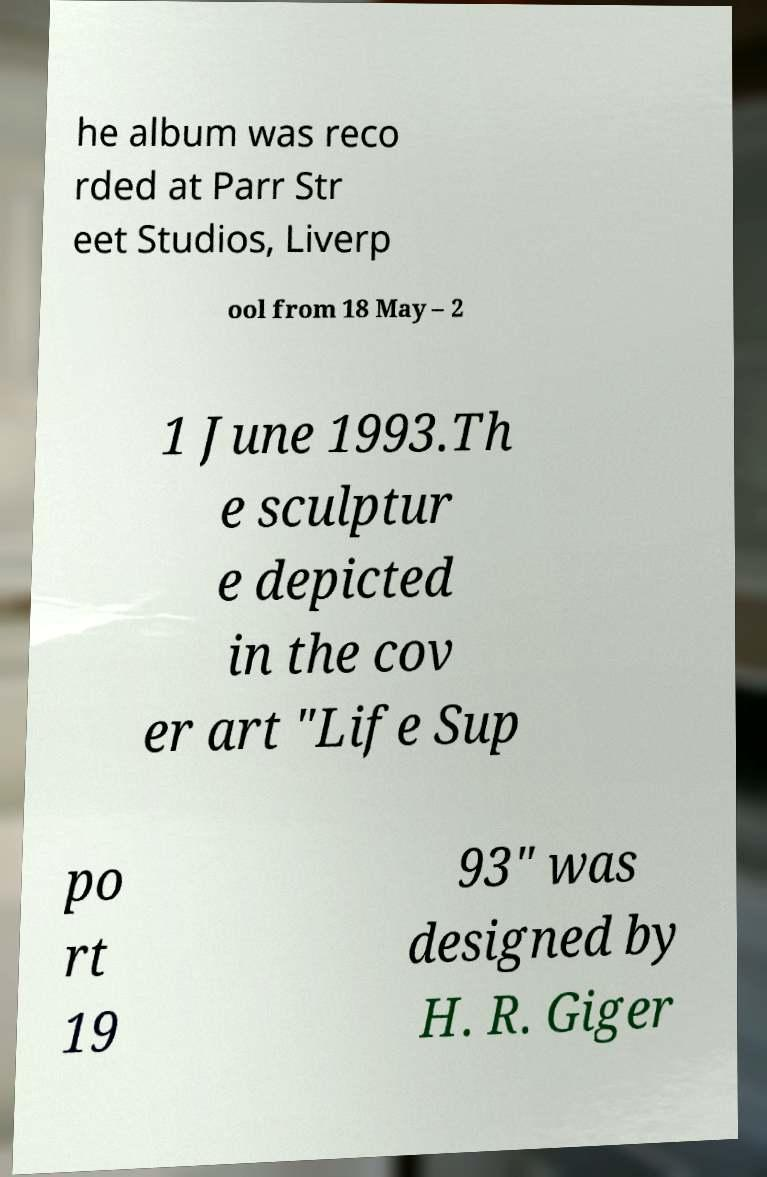I need the written content from this picture converted into text. Can you do that? he album was reco rded at Parr Str eet Studios, Liverp ool from 18 May – 2 1 June 1993.Th e sculptur e depicted in the cov er art "Life Sup po rt 19 93" was designed by H. R. Giger 